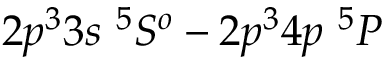<formula> <loc_0><loc_0><loc_500><loc_500>2 p ^ { 3 } 3 s ^ { 5 } S ^ { o } - 2 p ^ { 3 } 4 p ^ { 5 } P</formula> 